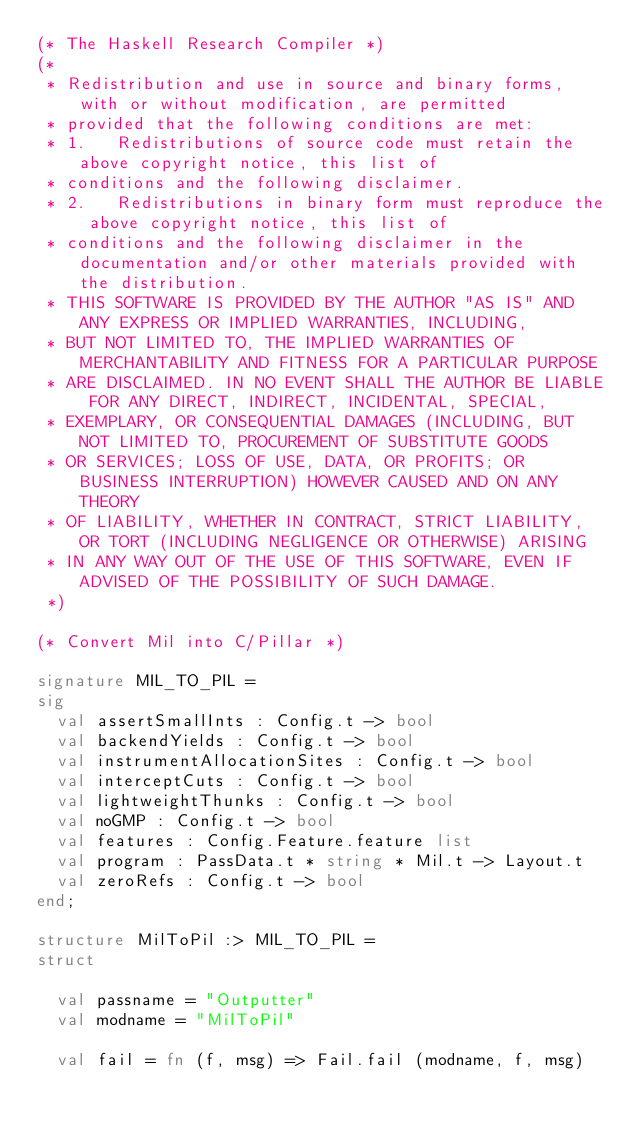Convert code to text. <code><loc_0><loc_0><loc_500><loc_500><_SML_>(* The Haskell Research Compiler *)
(*
 * Redistribution and use in source and binary forms, with or without modification, are permitted 
 * provided that the following conditions are met:
 * 1.   Redistributions of source code must retain the above copyright notice, this list of 
 * conditions and the following disclaimer.
 * 2.   Redistributions in binary form must reproduce the above copyright notice, this list of
 * conditions and the following disclaimer in the documentation and/or other materials provided with the distribution.
 * THIS SOFTWARE IS PROVIDED BY THE AUTHOR "AS IS" AND ANY EXPRESS OR IMPLIED WARRANTIES, INCLUDING,
 * BUT NOT LIMITED TO, THE IMPLIED WARRANTIES OF MERCHANTABILITY AND FITNESS FOR A PARTICULAR PURPOSE
 * ARE DISCLAIMED. IN NO EVENT SHALL THE AUTHOR BE LIABLE FOR ANY DIRECT, INDIRECT, INCIDENTAL, SPECIAL,
 * EXEMPLARY, OR CONSEQUENTIAL DAMAGES (INCLUDING, BUT NOT LIMITED TO, PROCUREMENT OF SUBSTITUTE GOODS
 * OR SERVICES; LOSS OF USE, DATA, OR PROFITS; OR BUSINESS INTERRUPTION) HOWEVER CAUSED AND ON ANY THEORY
 * OF LIABILITY, WHETHER IN CONTRACT, STRICT LIABILITY, OR TORT (INCLUDING NEGLIGENCE OR OTHERWISE) ARISING
 * IN ANY WAY OUT OF THE USE OF THIS SOFTWARE, EVEN IF ADVISED OF THE POSSIBILITY OF SUCH DAMAGE.
 *)

(* Convert Mil into C/Pillar *)

signature MIL_TO_PIL =
sig
  val assertSmallInts : Config.t -> bool
  val backendYields : Config.t -> bool
  val instrumentAllocationSites : Config.t -> bool
  val interceptCuts : Config.t -> bool
  val lightweightThunks : Config.t -> bool
  val noGMP : Config.t -> bool
  val features : Config.Feature.feature list
  val program : PassData.t * string * Mil.t -> Layout.t
  val zeroRefs : Config.t -> bool
end;

structure MilToPil :> MIL_TO_PIL =
struct

  val passname = "Outputter"
  val modname = "MilToPil"

  val fail = fn (f, msg) => Fail.fail (modname, f, msg)</code> 